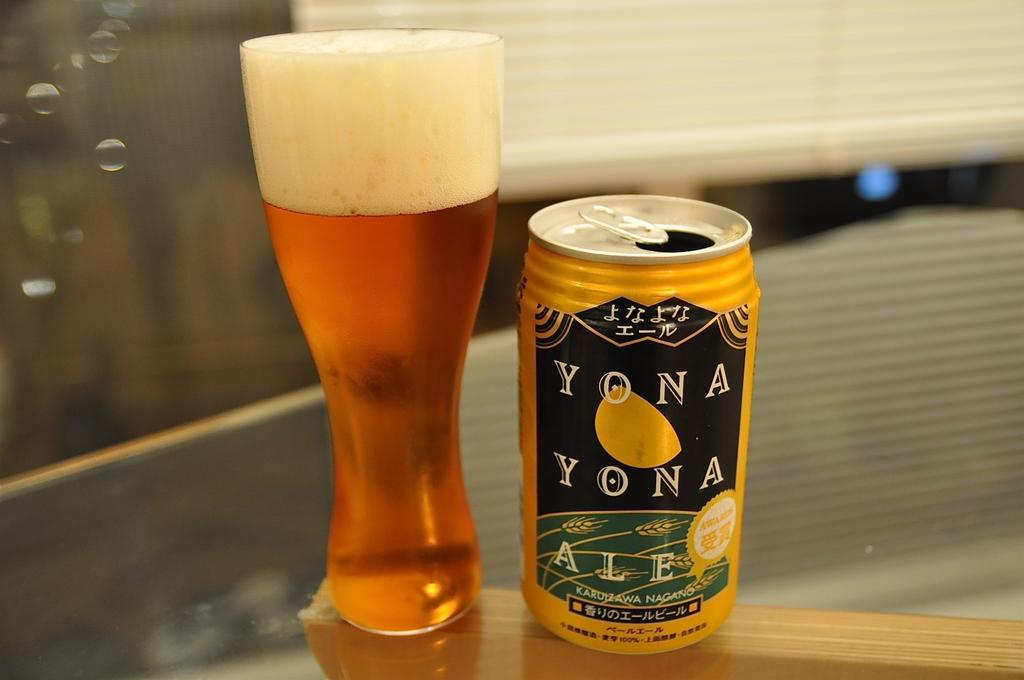<image>
Give a short and clear explanation of the subsequent image. A can of Yona Yona ale standing next to a glass 